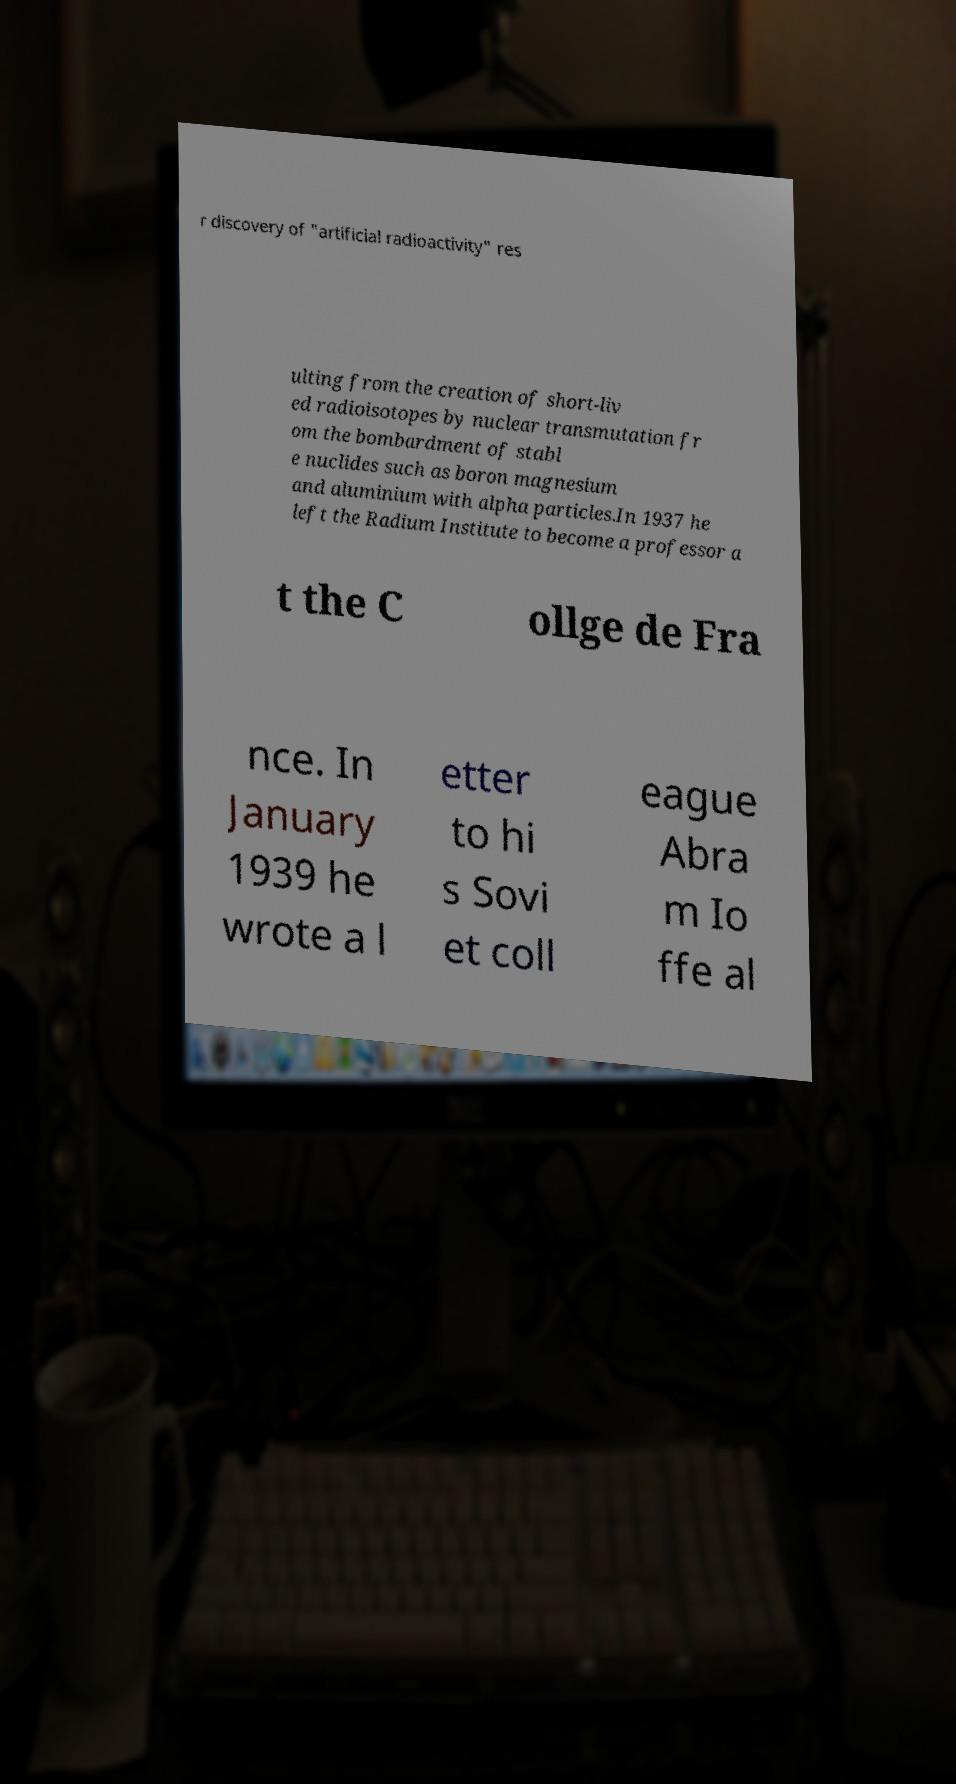Could you assist in decoding the text presented in this image and type it out clearly? r discovery of "artificial radioactivity" res ulting from the creation of short-liv ed radioisotopes by nuclear transmutation fr om the bombardment of stabl e nuclides such as boron magnesium and aluminium with alpha particles.In 1937 he left the Radium Institute to become a professor a t the C ollge de Fra nce. In January 1939 he wrote a l etter to hi s Sovi et coll eague Abra m Io ffe al 